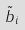Convert formula to latex. <formula><loc_0><loc_0><loc_500><loc_500>\tilde { b } _ { i }</formula> 